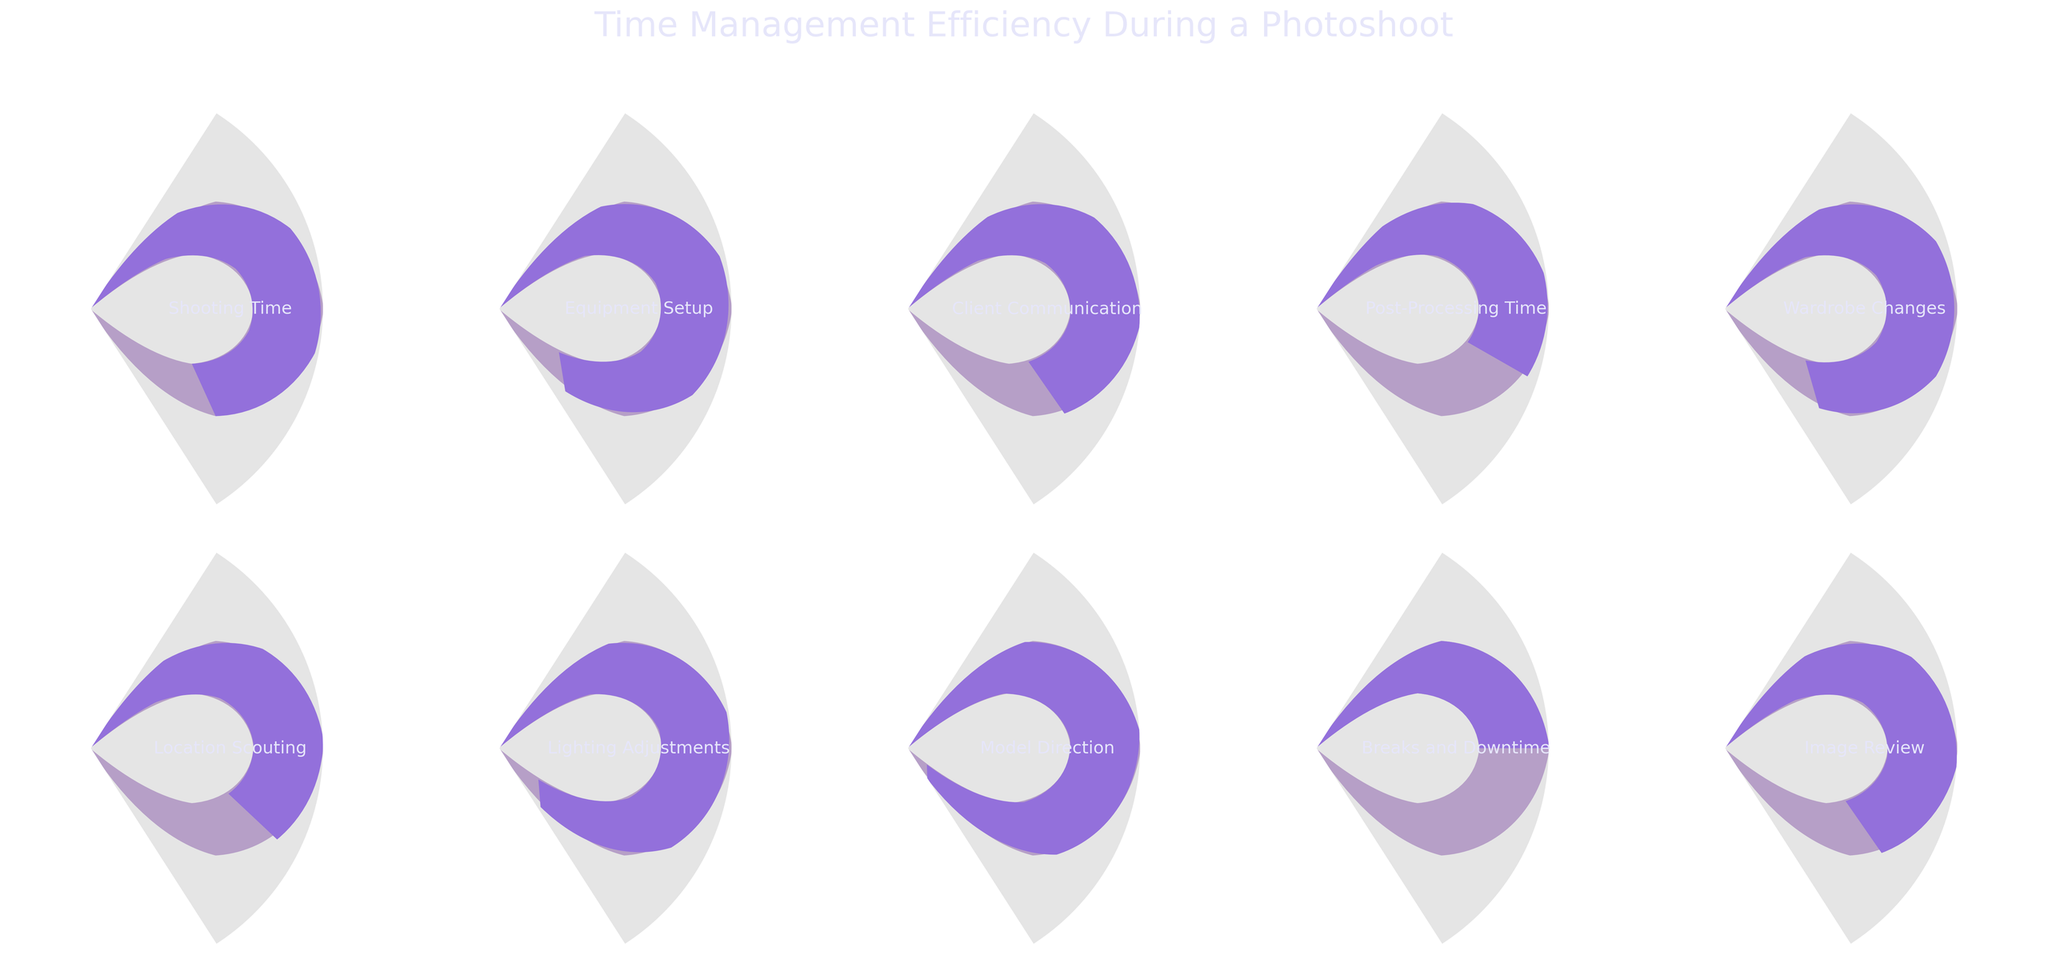Which task has the highest efficiency percentage? The gauge chart for Model Direction shows the highest efficiency at 95%.
Answer: Model Direction What is the title of the figure? The title is displayed at the top of the figure stating "Time Management Efficiency During a Photoshoot".
Answer: Time Management Efficiency During a Photoshoot Which tasks have an efficiency percentage below 70%? The tasks with efficiency percentages below 70% are Client Communication (70%), Post-Processing Time (60%), Location Scouting (65%), and Breaks and Downtime (50%).
Answer: Client Communication, Post-Processing Time, Location Scouting, Breaks and Downtime What is the average efficiency percentage across all tasks? Add all efficiency percentages: 75 + 85 + 70 + 60 + 80 + 65 + 90 + 95 + 50 + 70 = 740. Divide by the number of tasks, which is 10. The average is 740 / 10 = 74.
Answer: 74 Which task has the lowest efficiency percentage, and what is its value? The task Breaks and Downtime shows the lowest efficiency percentage at 50%.
Answer: Breaks and Downtime, 50% How many tasks have an efficiency percentage equal to or greater than 80%? The tasks with efficiencies equal to or greater than 80% are Equipment Setup (85%), Wardrobe Changes (80%), Lighting Adjustments (90%), and Model Direction (95%). That makes 4 tasks.
Answer: 4 Compare the efficiency of Shooting Time and Post-Processing Time. Shooting Time has an efficiency of 75%, while Post-Processing Time has an efficiency of 60%. Shooting Time is higher.
Answer: Shooting Time is higher What is the median efficiency percentage of the tasks? First, list the efficiencies in numerical order: 50, 60, 65, 70, 70, 75, 80, 85, 90, 95. The median is the average of the 5th and 6th values (70 and 75). (70 + 75) / 2 = 72.5.
Answer: 72.5 Which task related to visual aspects of photos (e.g., lighting, direction) is the most efficient? The gauge chart for Model Direction, related to visual aspects of photos, shows the highest efficiency at 95%.
Answer: Model Direction What is the difference in efficiency percentage between the task 'Wardrobe Changes' and 'Breaks and Downtime'? Wardrobe Changes have an efficiency of 80%, and Breaks and Downtime have an efficiency of 50%. The difference is 80 - 50 = 30.
Answer: 30 